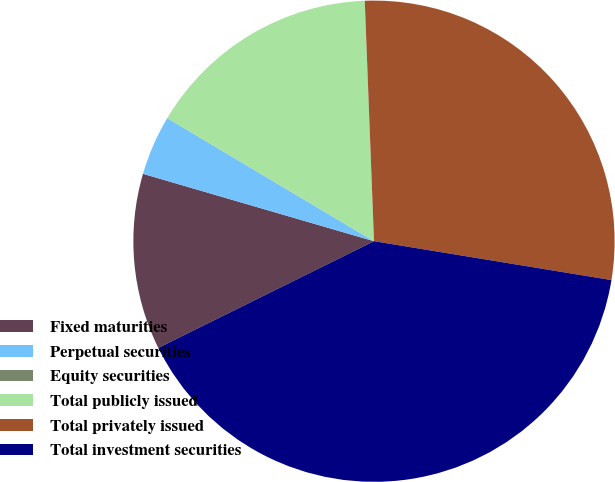Convert chart. <chart><loc_0><loc_0><loc_500><loc_500><pie_chart><fcel>Fixed maturities<fcel>Perpetual securities<fcel>Equity securities<fcel>Total publicly issued<fcel>Total privately issued<fcel>Total investment securities<nl><fcel>11.83%<fcel>4.02%<fcel>0.01%<fcel>15.84%<fcel>28.19%<fcel>40.1%<nl></chart> 